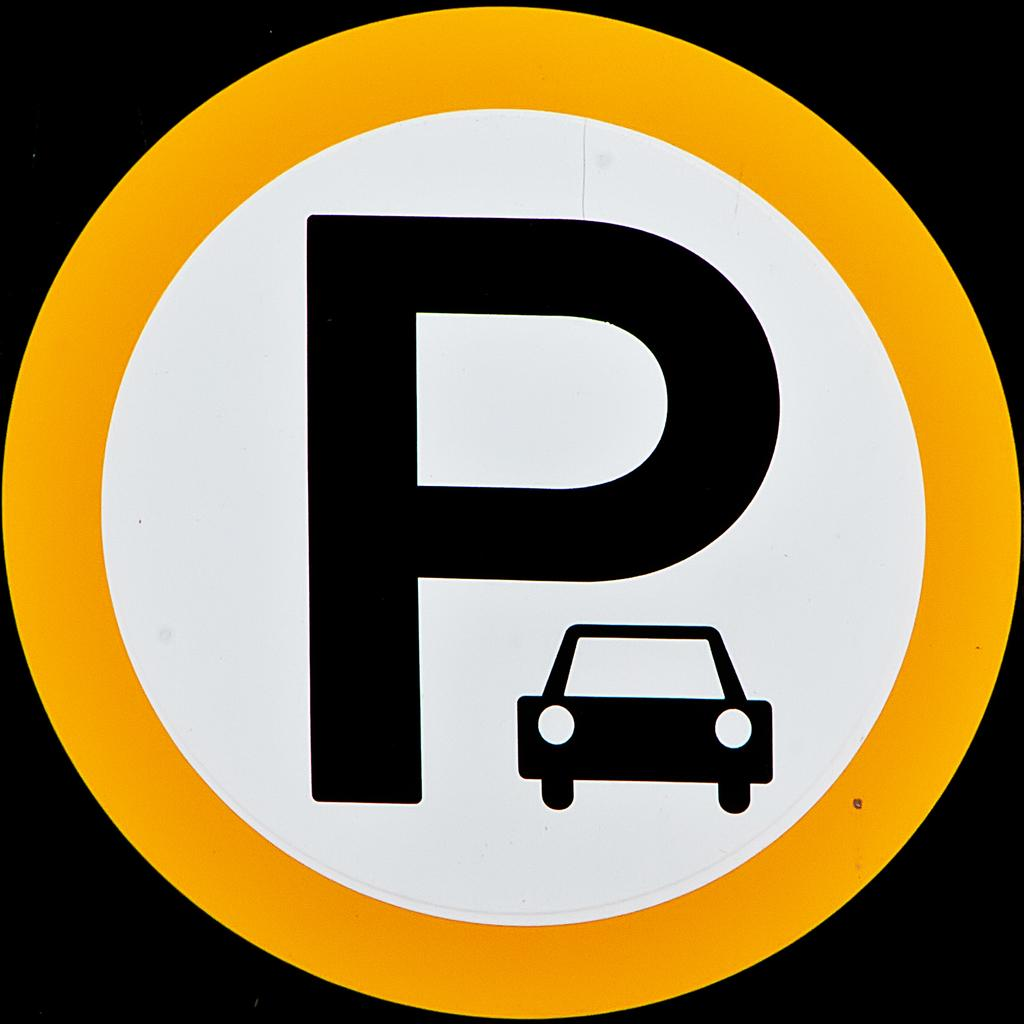What type of sign is present in the image? There is a caution sign in the image. What colors are used on the caution sign? The caution sign has white and yellow colors. How many ants can be seen crawling on the caution sign in the image? There are no ants present on the caution sign in the image. What type of boats are visible in the image? There are no boats present in the image. 